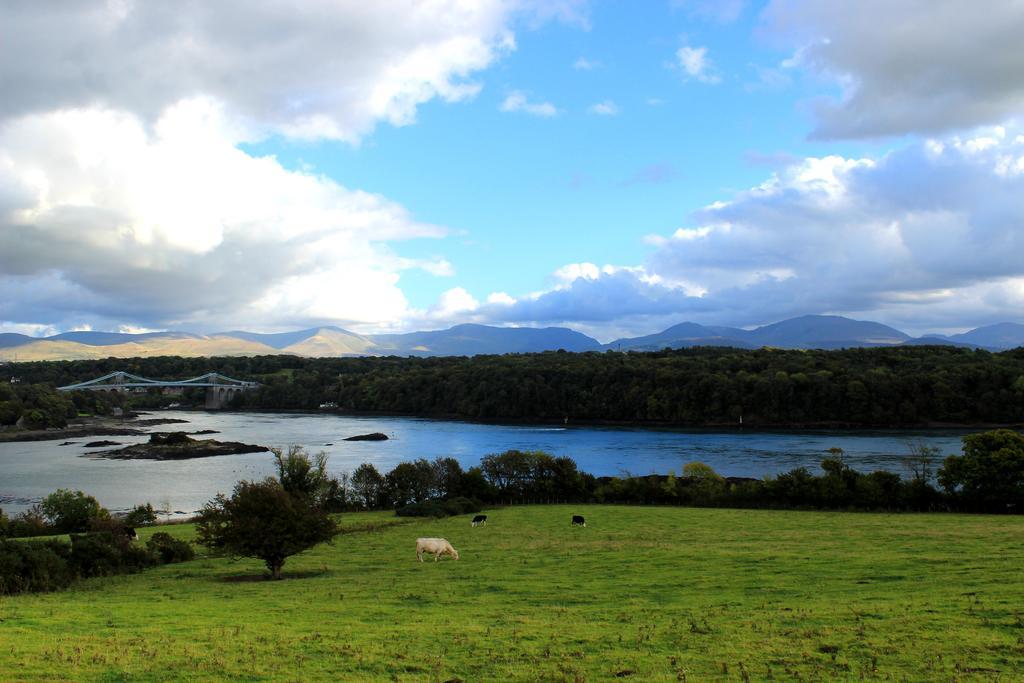In one or two sentences, can you explain what this image depicts? In this picture I can see water, trees and animals standing on the ground. In the background I can see mountains and the sky. Here I can see grass. 